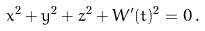<formula> <loc_0><loc_0><loc_500><loc_500>x ^ { 2 } + y ^ { 2 } + z ^ { 2 } + W ^ { \prime } ( t ) ^ { 2 } = 0 \, .</formula> 